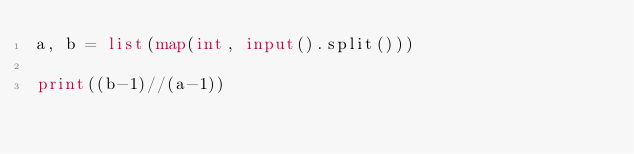<code> <loc_0><loc_0><loc_500><loc_500><_Python_>a, b = list(map(int, input().split()))

print((b-1)//(a-1))
</code> 